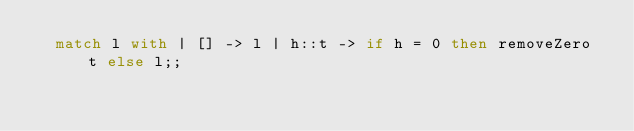<code> <loc_0><loc_0><loc_500><loc_500><_OCaml_>  match l with | [] -> l | h::t -> if h = 0 then removeZero t else l;;
</code> 